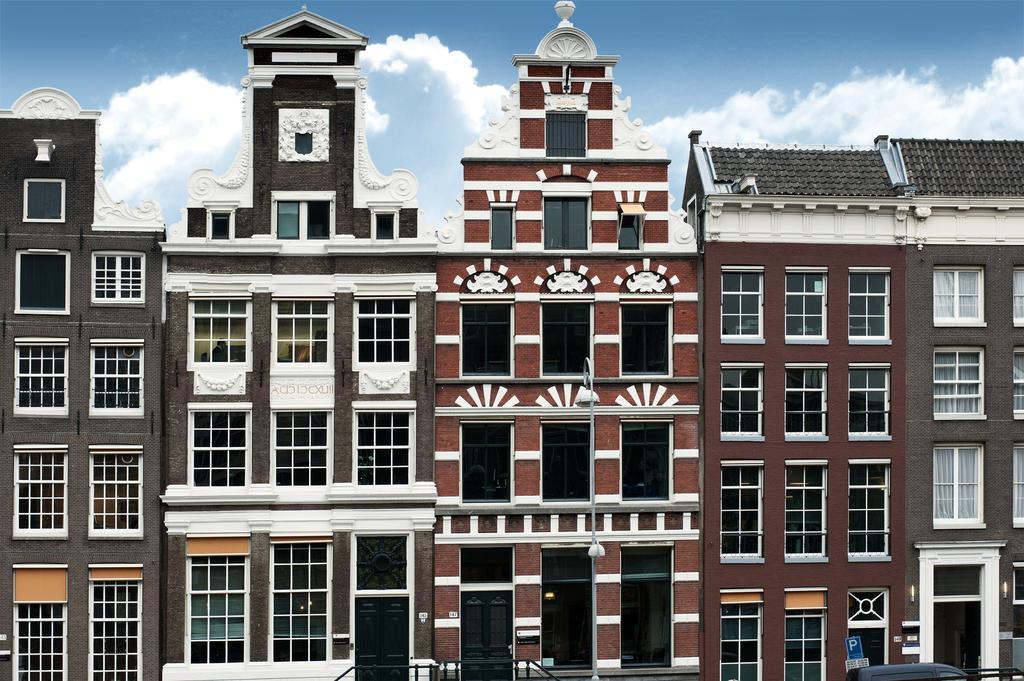What type of structures are present in the image? There are buildings in the image. What features can be observed on the buildings? The buildings have windows and curtains. What is the purpose of the signboard in the image? The signboard provides information or advertising in the image. What can be seen in the background of the image? The sky is visible in the background of the image, and there are clouds in the sky. Can you tell me how many maids are working in the building on the left side of the image? There is no information about maids or their work in the image; it only shows buildings, windows, curtains, a signboard, and the sky with clouds. 